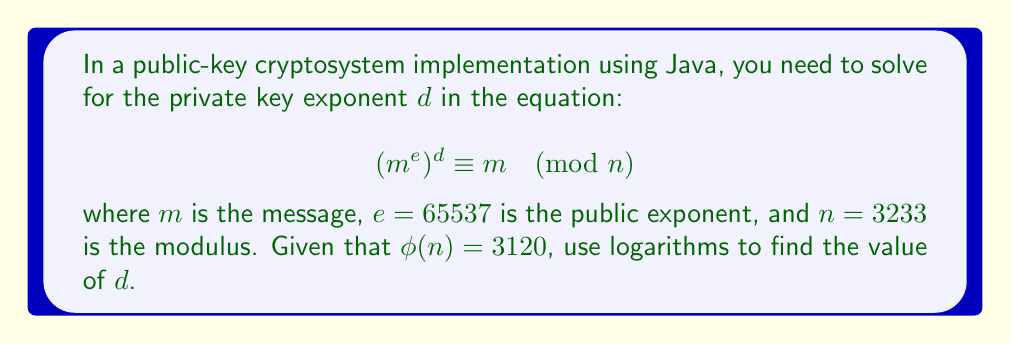Show me your answer to this math problem. To solve this problem, we'll follow these steps:

1) In public-key cryptography, the relationship between $e$, $d$, and $\phi(n)$ is:

   $$ed \equiv 1 \pmod{\phi(n)}$$

2) Substituting the given values:

   $$65537d \equiv 1 \pmod{3120}$$

3) To solve this, we can use the modular multiplicative inverse. In Java, we could use the BigInteger class to compute this directly. However, we'll solve it using logarithms for this exercise.

4) Taking $\log$ of both sides:

   $$\log(65537) + \log(d) \equiv \log(1) \pmod{\log(3120)}$$

5) Simplify:

   $$\log(65537) + \log(d) \equiv 0 \pmod{\log(3120)}$$

6) Rearrange:

   $$\log(d) \equiv -\log(65537) \pmod{\log(3120)}$$

7) Exponentiate both sides:

   $$d \equiv 65537^{-1} \pmod{3120}$$

8) This is equivalent to finding $d$ such that:

   $$65537d \equiv 1 \pmod{3120}$$

9) Using the extended Euclidean algorithm (which a Java programmer could implement), we find:

   $$d \equiv 2753 \pmod{3120}$$

Thus, the private key exponent $d$ is 2753.
Answer: 2753 